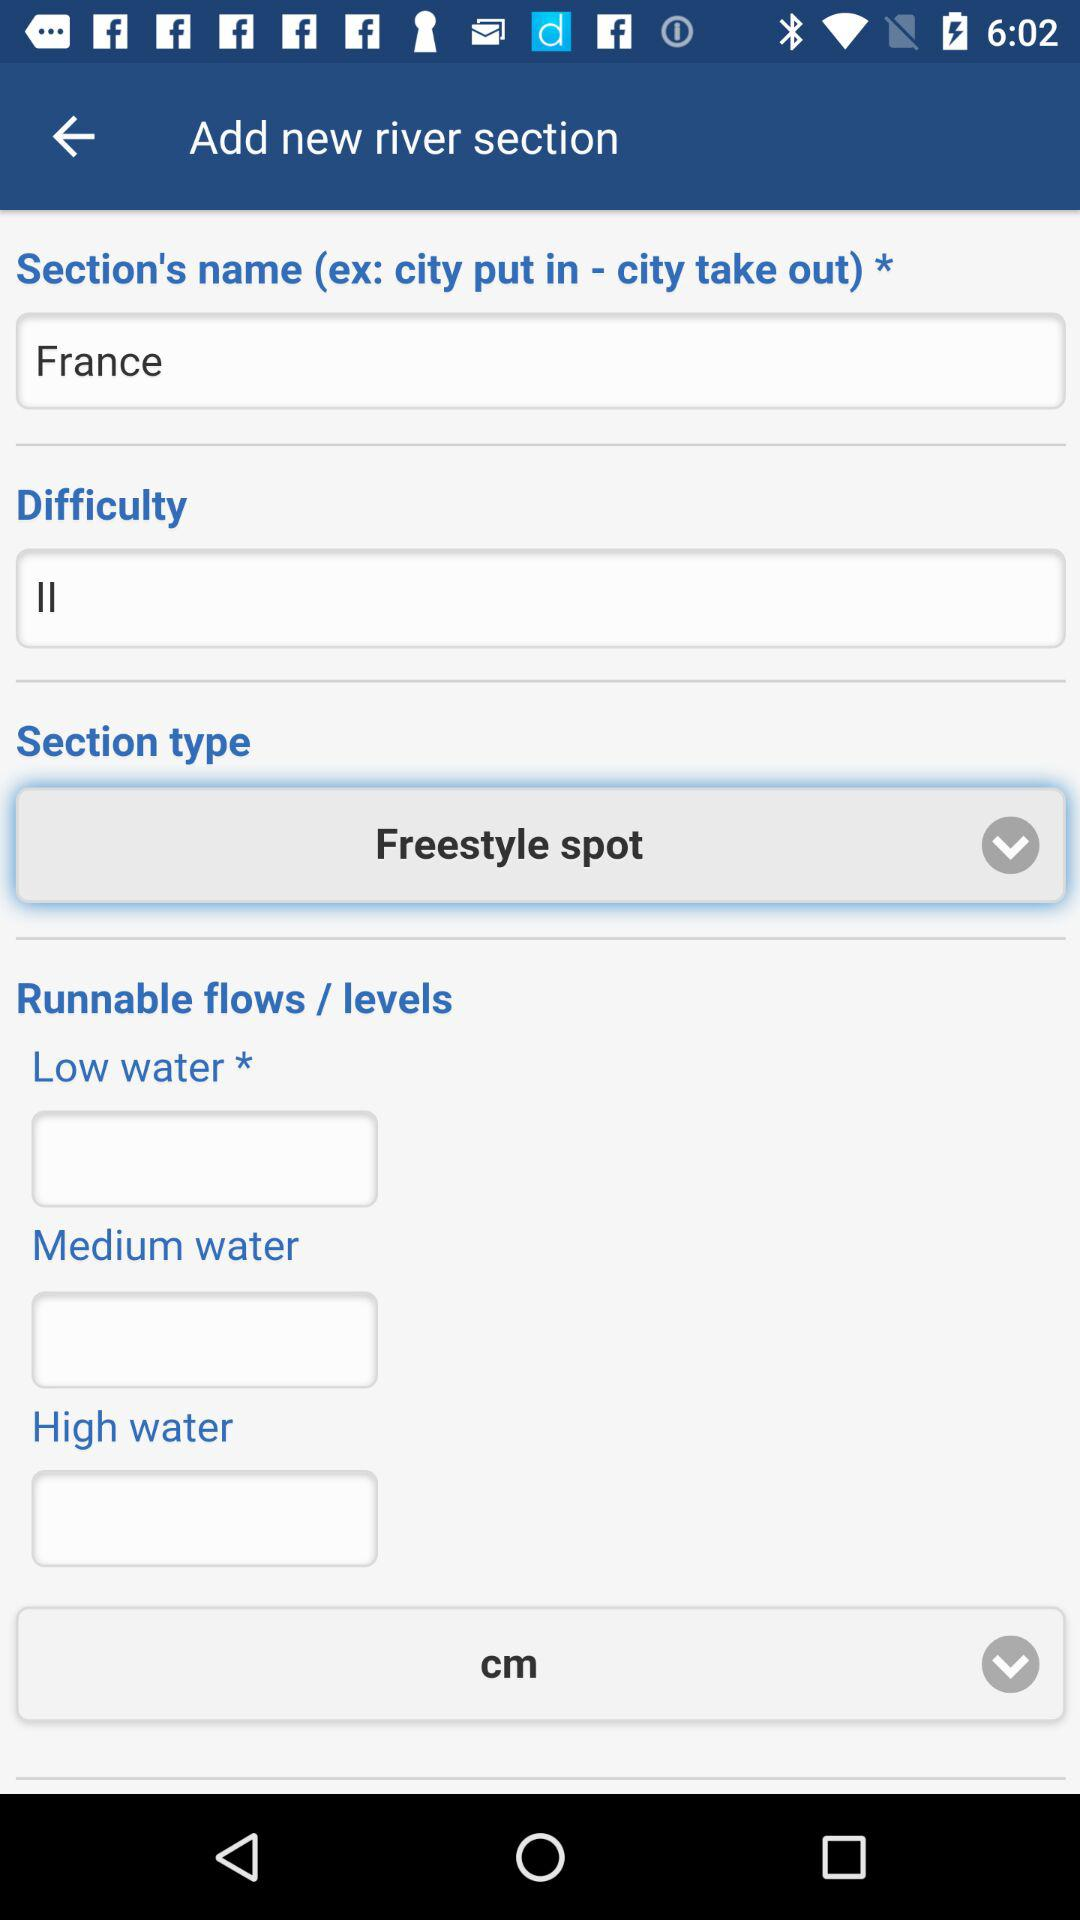What is the difficulty level? The difficulty level is "II". 